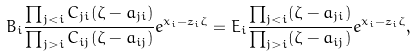<formula> <loc_0><loc_0><loc_500><loc_500>B _ { i } \frac { \prod _ { j < i } C _ { j i } ( \zeta - a _ { j i } ) } { \prod _ { j > i } C _ { i j } ( \zeta - a _ { i j } ) } e ^ { x _ { i } - \bar { z } _ { i } \zeta } = E _ { i } \frac { \prod _ { j < i } ( \zeta - a _ { j i } ) } { \prod _ { j > i } ( \zeta - a _ { i j } ) } e ^ { x _ { i } - \bar { z } _ { i } \zeta } ,</formula> 